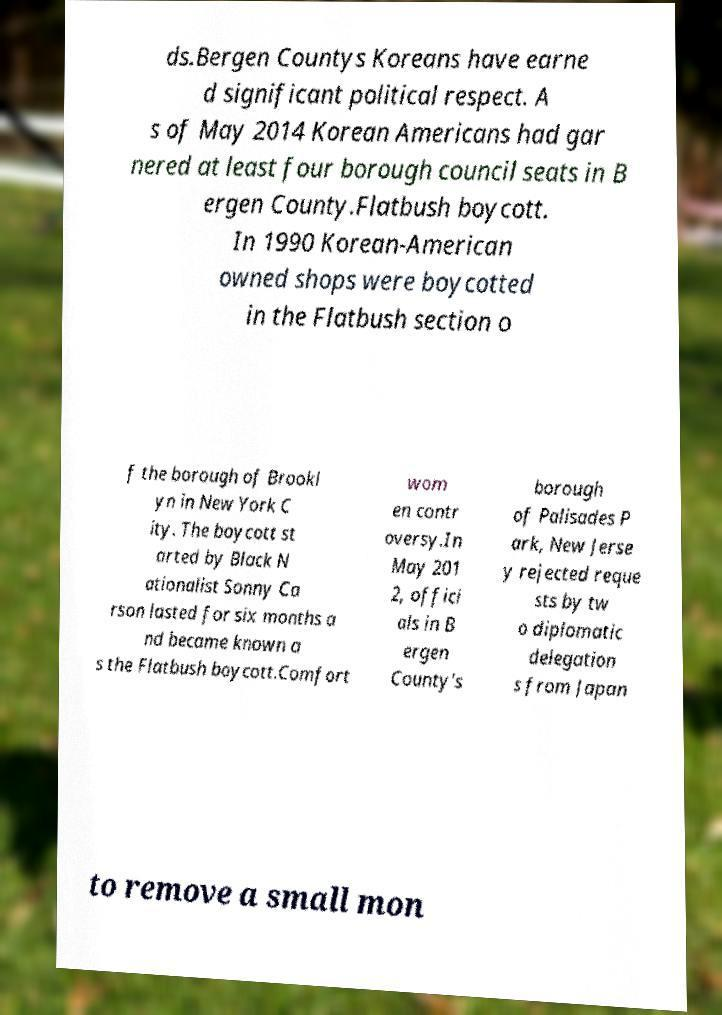For documentation purposes, I need the text within this image transcribed. Could you provide that? ds.Bergen Countys Koreans have earne d significant political respect. A s of May 2014 Korean Americans had gar nered at least four borough council seats in B ergen County.Flatbush boycott. In 1990 Korean-American owned shops were boycotted in the Flatbush section o f the borough of Brookl yn in New York C ity. The boycott st arted by Black N ationalist Sonny Ca rson lasted for six months a nd became known a s the Flatbush boycott.Comfort wom en contr oversy.In May 201 2, offici als in B ergen County's borough of Palisades P ark, New Jerse y rejected reque sts by tw o diplomatic delegation s from Japan to remove a small mon 